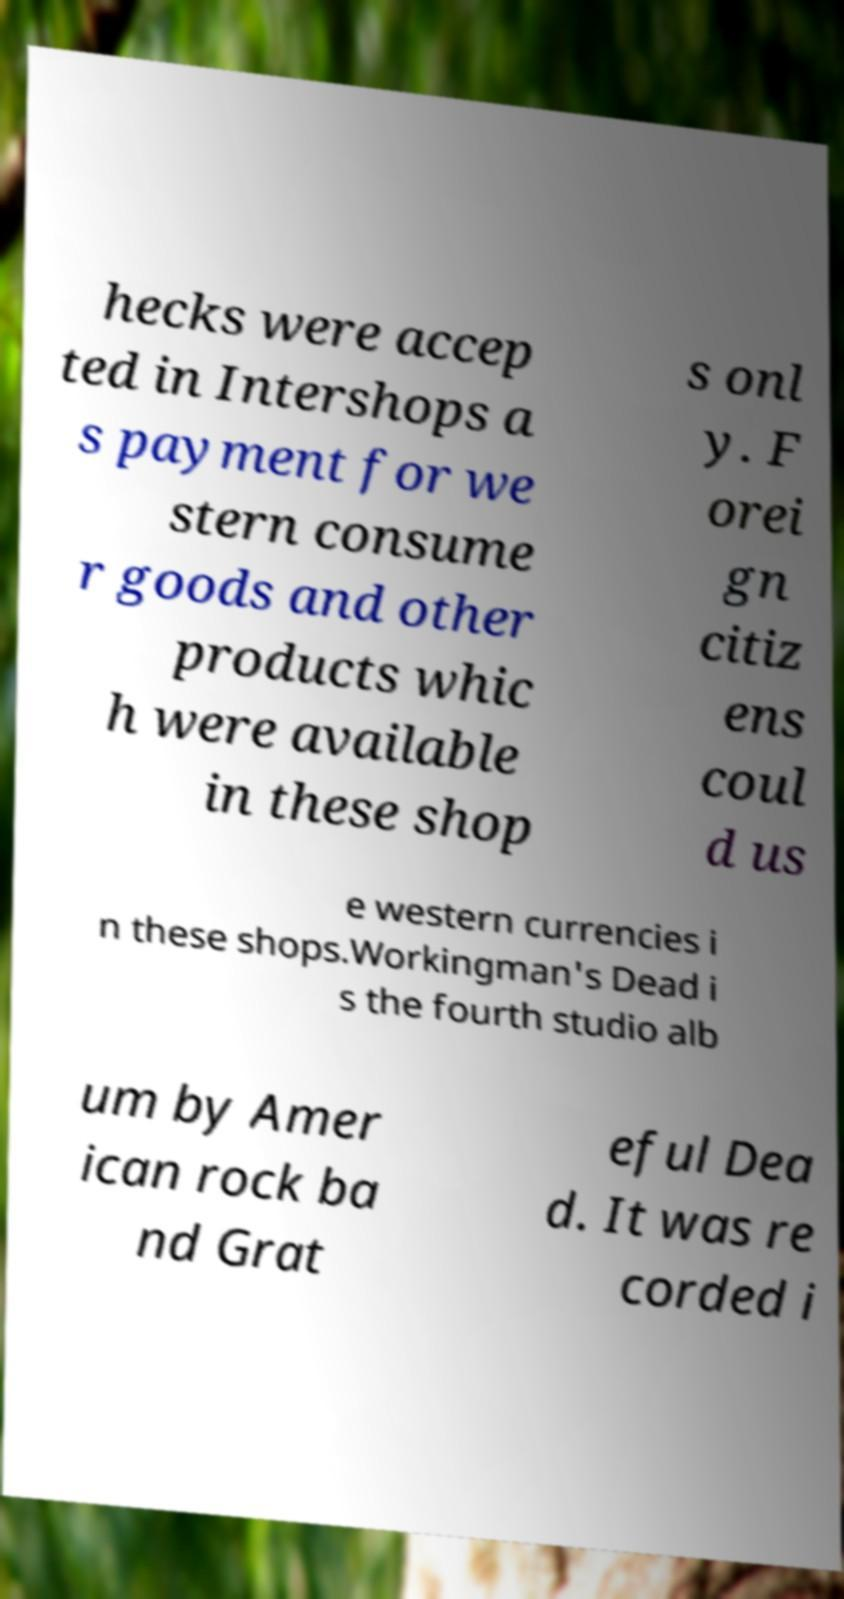For documentation purposes, I need the text within this image transcribed. Could you provide that? hecks were accep ted in Intershops a s payment for we stern consume r goods and other products whic h were available in these shop s onl y. F orei gn citiz ens coul d us e western currencies i n these shops.Workingman's Dead i s the fourth studio alb um by Amer ican rock ba nd Grat eful Dea d. It was re corded i 